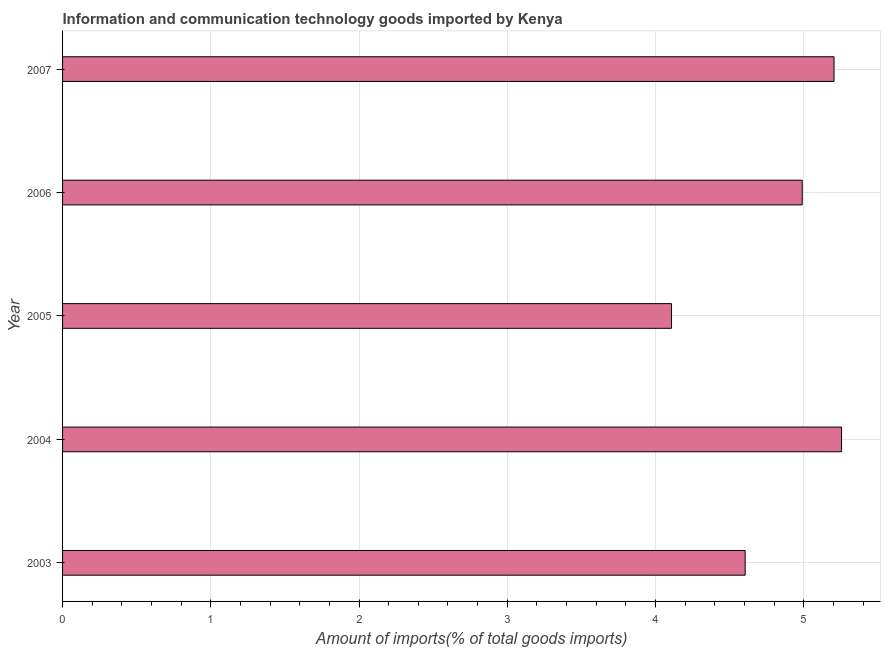Does the graph contain any zero values?
Provide a short and direct response. No. What is the title of the graph?
Offer a terse response. Information and communication technology goods imported by Kenya. What is the label or title of the X-axis?
Offer a very short reply. Amount of imports(% of total goods imports). What is the label or title of the Y-axis?
Provide a succinct answer. Year. What is the amount of ict goods imports in 2004?
Your response must be concise. 5.26. Across all years, what is the maximum amount of ict goods imports?
Offer a very short reply. 5.26. Across all years, what is the minimum amount of ict goods imports?
Your response must be concise. 4.11. In which year was the amount of ict goods imports minimum?
Provide a succinct answer. 2005. What is the sum of the amount of ict goods imports?
Ensure brevity in your answer.  24.16. What is the difference between the amount of ict goods imports in 2004 and 2007?
Your answer should be very brief. 0.05. What is the average amount of ict goods imports per year?
Offer a very short reply. 4.83. What is the median amount of ict goods imports?
Your response must be concise. 4.99. In how many years, is the amount of ict goods imports greater than 4.6 %?
Your answer should be very brief. 4. What is the ratio of the amount of ict goods imports in 2005 to that in 2006?
Your answer should be compact. 0.82. What is the difference between the highest and the second highest amount of ict goods imports?
Keep it short and to the point. 0.05. What is the difference between the highest and the lowest amount of ict goods imports?
Your answer should be very brief. 1.15. What is the difference between two consecutive major ticks on the X-axis?
Your answer should be very brief. 1. Are the values on the major ticks of X-axis written in scientific E-notation?
Offer a terse response. No. What is the Amount of imports(% of total goods imports) in 2003?
Make the answer very short. 4.6. What is the Amount of imports(% of total goods imports) of 2004?
Provide a short and direct response. 5.26. What is the Amount of imports(% of total goods imports) in 2005?
Offer a very short reply. 4.11. What is the Amount of imports(% of total goods imports) of 2006?
Ensure brevity in your answer.  4.99. What is the Amount of imports(% of total goods imports) of 2007?
Your response must be concise. 5.2. What is the difference between the Amount of imports(% of total goods imports) in 2003 and 2004?
Keep it short and to the point. -0.65. What is the difference between the Amount of imports(% of total goods imports) in 2003 and 2005?
Keep it short and to the point. 0.5. What is the difference between the Amount of imports(% of total goods imports) in 2003 and 2006?
Ensure brevity in your answer.  -0.38. What is the difference between the Amount of imports(% of total goods imports) in 2003 and 2007?
Your response must be concise. -0.6. What is the difference between the Amount of imports(% of total goods imports) in 2004 and 2005?
Offer a very short reply. 1.15. What is the difference between the Amount of imports(% of total goods imports) in 2004 and 2006?
Your answer should be compact. 0.27. What is the difference between the Amount of imports(% of total goods imports) in 2004 and 2007?
Provide a short and direct response. 0.05. What is the difference between the Amount of imports(% of total goods imports) in 2005 and 2006?
Offer a very short reply. -0.88. What is the difference between the Amount of imports(% of total goods imports) in 2005 and 2007?
Offer a terse response. -1.1. What is the difference between the Amount of imports(% of total goods imports) in 2006 and 2007?
Offer a very short reply. -0.21. What is the ratio of the Amount of imports(% of total goods imports) in 2003 to that in 2004?
Ensure brevity in your answer.  0.88. What is the ratio of the Amount of imports(% of total goods imports) in 2003 to that in 2005?
Your answer should be very brief. 1.12. What is the ratio of the Amount of imports(% of total goods imports) in 2003 to that in 2006?
Ensure brevity in your answer.  0.92. What is the ratio of the Amount of imports(% of total goods imports) in 2003 to that in 2007?
Give a very brief answer. 0.89. What is the ratio of the Amount of imports(% of total goods imports) in 2004 to that in 2005?
Offer a very short reply. 1.28. What is the ratio of the Amount of imports(% of total goods imports) in 2004 to that in 2006?
Keep it short and to the point. 1.05. What is the ratio of the Amount of imports(% of total goods imports) in 2005 to that in 2006?
Your answer should be very brief. 0.82. What is the ratio of the Amount of imports(% of total goods imports) in 2005 to that in 2007?
Provide a short and direct response. 0.79. What is the ratio of the Amount of imports(% of total goods imports) in 2006 to that in 2007?
Ensure brevity in your answer.  0.96. 